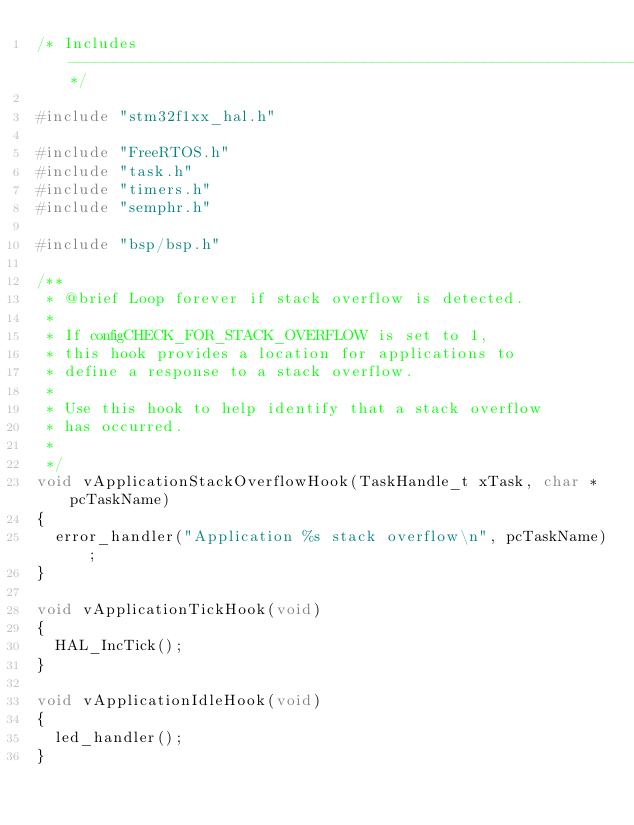Convert code to text. <code><loc_0><loc_0><loc_500><loc_500><_C_>/* Includes ------------------------------------------------------------------*/

#include "stm32f1xx_hal.h"

#include "FreeRTOS.h"
#include "task.h"
#include "timers.h"
#include "semphr.h"

#include "bsp/bsp.h"

/**
 * @brief Loop forever if stack overflow is detected.
 *
 * If configCHECK_FOR_STACK_OVERFLOW is set to 1,
 * this hook provides a location for applications to
 * define a response to a stack overflow.
 *
 * Use this hook to help identify that a stack overflow
 * has occurred.
 *
 */
void vApplicationStackOverflowHook(TaskHandle_t xTask, char * pcTaskName)
{
  error_handler("Application %s stack overflow\n", pcTaskName);
}

void vApplicationTickHook(void)
{
  HAL_IncTick();
}

void vApplicationIdleHook(void)
{
  led_handler();
}
</code> 